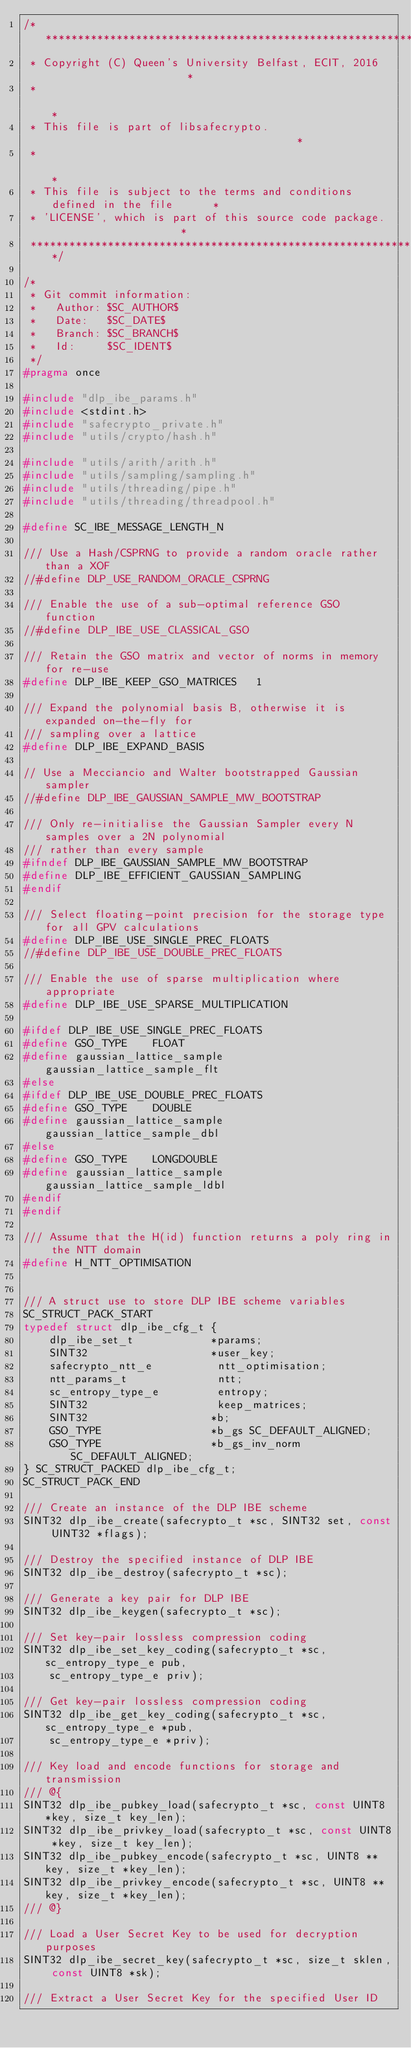Convert code to text. <code><loc_0><loc_0><loc_500><loc_500><_C_>/*****************************************************************************
 * Copyright (C) Queen's University Belfast, ECIT, 2016                      *
 *                                                                           *
 * This file is part of libsafecrypto.                                       *
 *                                                                           *
 * This file is subject to the terms and conditions defined in the file      *
 * 'LICENSE', which is part of this source code package.                     *
 *****************************************************************************/

/*
 * Git commit information:
 *   Author: $SC_AUTHOR$
 *   Date:   $SC_DATE$
 *   Branch: $SC_BRANCH$
 *   Id:     $SC_IDENT$
 */
#pragma once

#include "dlp_ibe_params.h"
#include <stdint.h>
#include "safecrypto_private.h"
#include "utils/crypto/hash.h"

#include "utils/arith/arith.h"
#include "utils/sampling/sampling.h"
#include "utils/threading/pipe.h"
#include "utils/threading/threadpool.h"

#define SC_IBE_MESSAGE_LENGTH_N

/// Use a Hash/CSPRNG to provide a random oracle rather than a XOF
//#define DLP_USE_RANDOM_ORACLE_CSPRNG

/// Enable the use of a sub-optimal reference GSO function
//#define DLP_IBE_USE_CLASSICAL_GSO

/// Retain the GSO matrix and vector of norms in memory for re-use
#define DLP_IBE_KEEP_GSO_MATRICES   1

/// Expand the polynomial basis B, otherwise it is expanded on-the-fly for
/// sampling over a lattice
#define DLP_IBE_EXPAND_BASIS

// Use a Mecciancio and Walter bootstrapped Gaussian sampler
//#define DLP_IBE_GAUSSIAN_SAMPLE_MW_BOOTSTRAP

/// Only re-initialise the Gaussian Sampler every N samples over a 2N polynomial
/// rather than every sample
#ifndef DLP_IBE_GAUSSIAN_SAMPLE_MW_BOOTSTRAP
#define DLP_IBE_EFFICIENT_GAUSSIAN_SAMPLING
#endif

/// Select floating-point precision for the storage type for all GPV calculations
#define DLP_IBE_USE_SINGLE_PREC_FLOATS
//#define DLP_IBE_USE_DOUBLE_PREC_FLOATS

/// Enable the use of sparse multiplication where appropriate
#define DLP_IBE_USE_SPARSE_MULTIPLICATION

#ifdef DLP_IBE_USE_SINGLE_PREC_FLOATS
#define GSO_TYPE    FLOAT
#define gaussian_lattice_sample gaussian_lattice_sample_flt
#else
#ifdef DLP_IBE_USE_DOUBLE_PREC_FLOATS
#define GSO_TYPE    DOUBLE
#define gaussian_lattice_sample gaussian_lattice_sample_dbl
#else
#define GSO_TYPE    LONGDOUBLE
#define gaussian_lattice_sample gaussian_lattice_sample_ldbl
#endif
#endif

/// Assume that the H(id) function returns a poly ring in the NTT domain
#define H_NTT_OPTIMISATION


/// A struct use to store DLP IBE scheme variables
SC_STRUCT_PACK_START
typedef struct dlp_ibe_cfg_t {
    dlp_ibe_set_t            *params;
    SINT32                   *user_key;
    safecrypto_ntt_e          ntt_optimisation;
    ntt_params_t              ntt;
    sc_entropy_type_e         entropy;
    SINT32                    keep_matrices;
    SINT32                   *b;
    GSO_TYPE                 *b_gs SC_DEFAULT_ALIGNED;
    GSO_TYPE                 *b_gs_inv_norm SC_DEFAULT_ALIGNED;
} SC_STRUCT_PACKED dlp_ibe_cfg_t;
SC_STRUCT_PACK_END

/// Create an instance of the DLP IBE scheme
SINT32 dlp_ibe_create(safecrypto_t *sc, SINT32 set, const UINT32 *flags);

/// Destroy the specified instance of DLP IBE
SINT32 dlp_ibe_destroy(safecrypto_t *sc);

/// Generate a key pair for DLP IBE
SINT32 dlp_ibe_keygen(safecrypto_t *sc);

/// Set key-pair lossless compression coding
SINT32 dlp_ibe_set_key_coding(safecrypto_t *sc, sc_entropy_type_e pub,
    sc_entropy_type_e priv);

/// Get key-pair lossless compression coding
SINT32 dlp_ibe_get_key_coding(safecrypto_t *sc, sc_entropy_type_e *pub,
    sc_entropy_type_e *priv);

/// Key load and encode functions for storage and transmission
/// @{
SINT32 dlp_ibe_pubkey_load(safecrypto_t *sc, const UINT8 *key, size_t key_len);
SINT32 dlp_ibe_privkey_load(safecrypto_t *sc, const UINT8 *key, size_t key_len);
SINT32 dlp_ibe_pubkey_encode(safecrypto_t *sc, UINT8 **key, size_t *key_len);
SINT32 dlp_ibe_privkey_encode(safecrypto_t *sc, UINT8 **key, size_t *key_len);
/// @}

/// Load a User Secret Key to be used for decryption purposes
SINT32 dlp_ibe_secret_key(safecrypto_t *sc, size_t sklen, const UINT8 *sk);

/// Extract a User Secret Key for the specified User ID</code> 